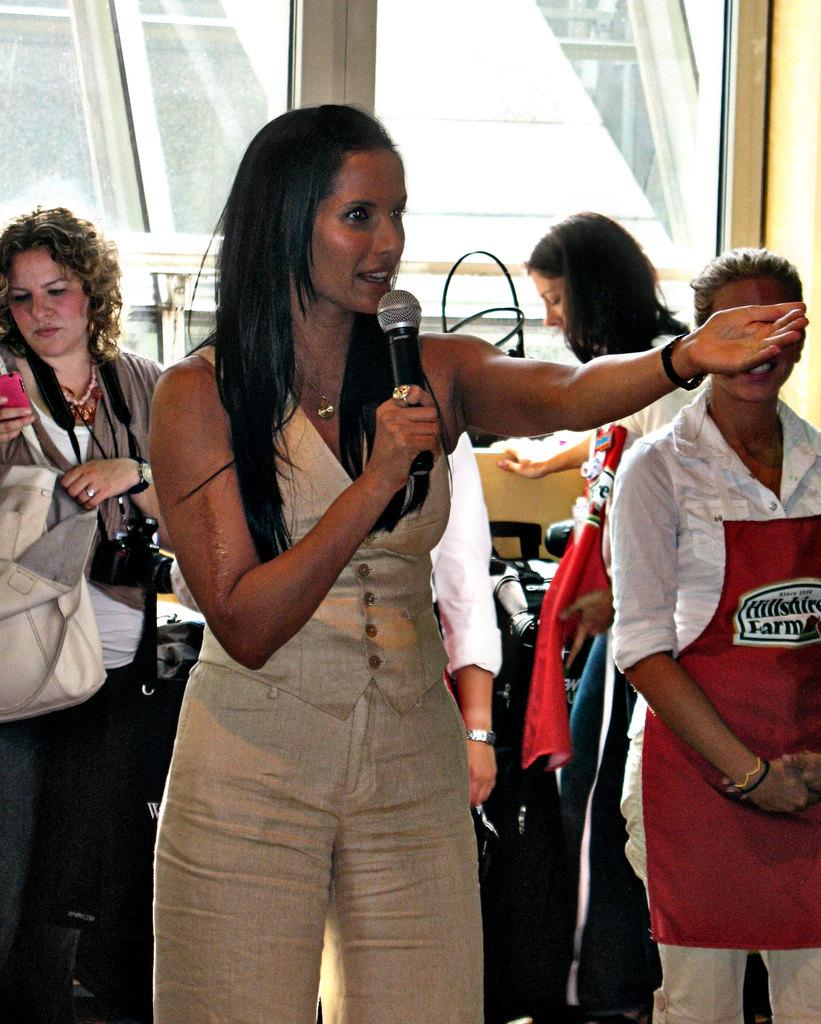Who is the main subject in the image? There is a woman in the image. What is the woman holding in her hand? The woman is holding a mic in her hand. What is the woman doing with the mic? The woman is talking. Can you describe the background of the image? There are people standing in the background of the image. What architectural feature can be seen in the image? There is a window visible in the image. What type of muscle can be seen flexing in the image? There is no muscle visible in the image; it features a woman holding a mic and talking. 